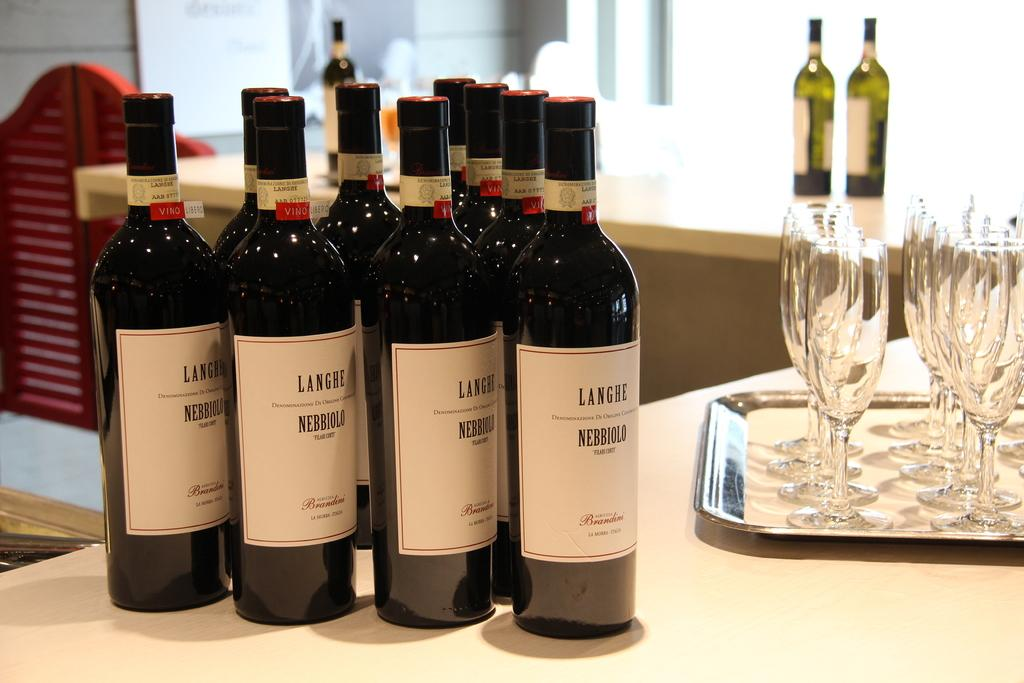What can be found on the table in the image? There are wine bottles on the table. What else is present on the table? There are glasses in a tray on the table. Are there any other bottles visible in the image? Yes, there are two bottles visible in the background. What story is being told in the notebook on the table? There is no notebook present in the image, so no story can be told from it. 